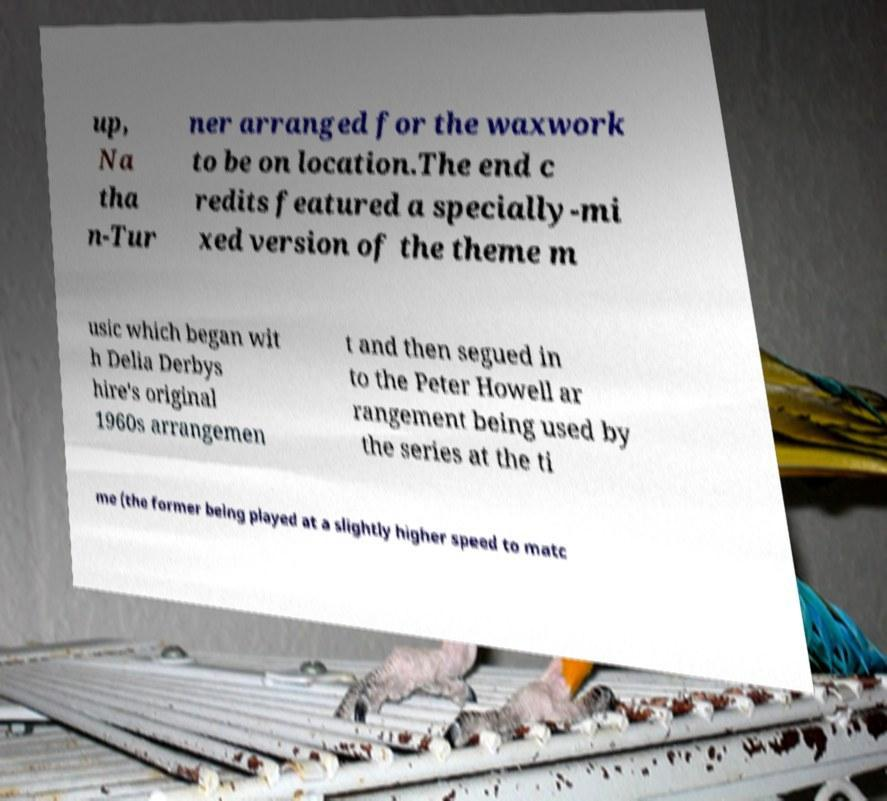Could you assist in decoding the text presented in this image and type it out clearly? up, Na tha n-Tur ner arranged for the waxwork to be on location.The end c redits featured a specially-mi xed version of the theme m usic which began wit h Delia Derbys hire's original 1960s arrangemen t and then segued in to the Peter Howell ar rangement being used by the series at the ti me (the former being played at a slightly higher speed to matc 